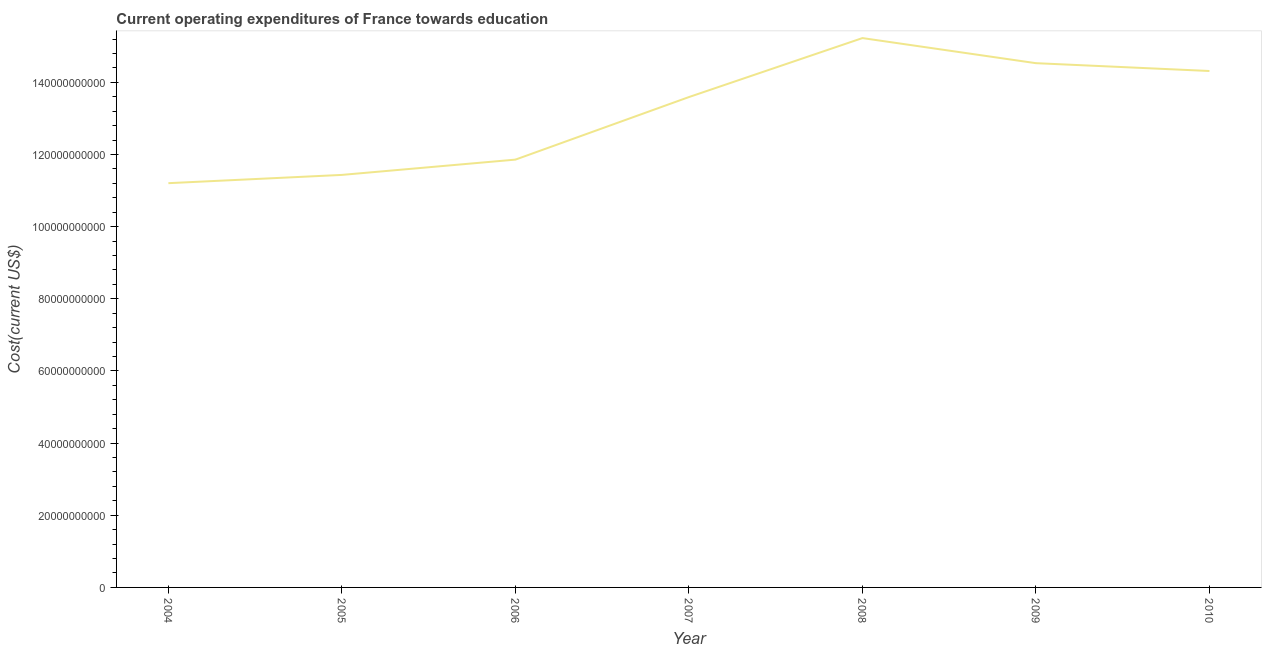What is the education expenditure in 2004?
Offer a very short reply. 1.12e+11. Across all years, what is the maximum education expenditure?
Your answer should be very brief. 1.52e+11. Across all years, what is the minimum education expenditure?
Keep it short and to the point. 1.12e+11. In which year was the education expenditure maximum?
Provide a short and direct response. 2008. In which year was the education expenditure minimum?
Offer a very short reply. 2004. What is the sum of the education expenditure?
Provide a succinct answer. 9.22e+11. What is the difference between the education expenditure in 2005 and 2008?
Your answer should be compact. -3.79e+1. What is the average education expenditure per year?
Provide a succinct answer. 1.32e+11. What is the median education expenditure?
Keep it short and to the point. 1.36e+11. Do a majority of the years between 2004 and 2005 (inclusive) have education expenditure greater than 88000000000 US$?
Offer a very short reply. Yes. What is the ratio of the education expenditure in 2004 to that in 2010?
Offer a terse response. 0.78. Is the education expenditure in 2005 less than that in 2007?
Your answer should be very brief. Yes. Is the difference between the education expenditure in 2006 and 2009 greater than the difference between any two years?
Keep it short and to the point. No. What is the difference between the highest and the second highest education expenditure?
Provide a short and direct response. 6.96e+09. Is the sum of the education expenditure in 2004 and 2005 greater than the maximum education expenditure across all years?
Offer a terse response. Yes. What is the difference between the highest and the lowest education expenditure?
Provide a short and direct response. 4.02e+1. In how many years, is the education expenditure greater than the average education expenditure taken over all years?
Your answer should be very brief. 4. Does the education expenditure monotonically increase over the years?
Give a very brief answer. No. Are the values on the major ticks of Y-axis written in scientific E-notation?
Provide a succinct answer. No. Does the graph contain grids?
Provide a short and direct response. No. What is the title of the graph?
Your response must be concise. Current operating expenditures of France towards education. What is the label or title of the X-axis?
Ensure brevity in your answer.  Year. What is the label or title of the Y-axis?
Ensure brevity in your answer.  Cost(current US$). What is the Cost(current US$) in 2004?
Your answer should be compact. 1.12e+11. What is the Cost(current US$) in 2005?
Your response must be concise. 1.14e+11. What is the Cost(current US$) in 2006?
Keep it short and to the point. 1.19e+11. What is the Cost(current US$) of 2007?
Keep it short and to the point. 1.36e+11. What is the Cost(current US$) of 2008?
Your response must be concise. 1.52e+11. What is the Cost(current US$) in 2009?
Your response must be concise. 1.45e+11. What is the Cost(current US$) of 2010?
Provide a succinct answer. 1.43e+11. What is the difference between the Cost(current US$) in 2004 and 2005?
Keep it short and to the point. -2.29e+09. What is the difference between the Cost(current US$) in 2004 and 2006?
Make the answer very short. -6.53e+09. What is the difference between the Cost(current US$) in 2004 and 2007?
Keep it short and to the point. -2.39e+1. What is the difference between the Cost(current US$) in 2004 and 2008?
Your answer should be compact. -4.02e+1. What is the difference between the Cost(current US$) in 2004 and 2009?
Your answer should be compact. -3.33e+1. What is the difference between the Cost(current US$) in 2004 and 2010?
Provide a succinct answer. -3.11e+1. What is the difference between the Cost(current US$) in 2005 and 2006?
Your answer should be compact. -4.24e+09. What is the difference between the Cost(current US$) in 2005 and 2007?
Offer a terse response. -2.16e+1. What is the difference between the Cost(current US$) in 2005 and 2008?
Provide a short and direct response. -3.79e+1. What is the difference between the Cost(current US$) in 2005 and 2009?
Make the answer very short. -3.10e+1. What is the difference between the Cost(current US$) in 2005 and 2010?
Ensure brevity in your answer.  -2.88e+1. What is the difference between the Cost(current US$) in 2006 and 2007?
Ensure brevity in your answer.  -1.73e+1. What is the difference between the Cost(current US$) in 2006 and 2008?
Your answer should be compact. -3.37e+1. What is the difference between the Cost(current US$) in 2006 and 2009?
Make the answer very short. -2.67e+1. What is the difference between the Cost(current US$) in 2006 and 2010?
Give a very brief answer. -2.46e+1. What is the difference between the Cost(current US$) in 2007 and 2008?
Ensure brevity in your answer.  -1.64e+1. What is the difference between the Cost(current US$) in 2007 and 2009?
Offer a terse response. -9.40e+09. What is the difference between the Cost(current US$) in 2007 and 2010?
Offer a terse response. -7.23e+09. What is the difference between the Cost(current US$) in 2008 and 2009?
Your answer should be compact. 6.96e+09. What is the difference between the Cost(current US$) in 2008 and 2010?
Your answer should be compact. 9.13e+09. What is the difference between the Cost(current US$) in 2009 and 2010?
Provide a short and direct response. 2.17e+09. What is the ratio of the Cost(current US$) in 2004 to that in 2006?
Give a very brief answer. 0.94. What is the ratio of the Cost(current US$) in 2004 to that in 2007?
Keep it short and to the point. 0.82. What is the ratio of the Cost(current US$) in 2004 to that in 2008?
Make the answer very short. 0.74. What is the ratio of the Cost(current US$) in 2004 to that in 2009?
Your response must be concise. 0.77. What is the ratio of the Cost(current US$) in 2004 to that in 2010?
Your answer should be very brief. 0.78. What is the ratio of the Cost(current US$) in 2005 to that in 2007?
Provide a short and direct response. 0.84. What is the ratio of the Cost(current US$) in 2005 to that in 2008?
Make the answer very short. 0.75. What is the ratio of the Cost(current US$) in 2005 to that in 2009?
Give a very brief answer. 0.79. What is the ratio of the Cost(current US$) in 2005 to that in 2010?
Provide a succinct answer. 0.8. What is the ratio of the Cost(current US$) in 2006 to that in 2007?
Make the answer very short. 0.87. What is the ratio of the Cost(current US$) in 2006 to that in 2008?
Your response must be concise. 0.78. What is the ratio of the Cost(current US$) in 2006 to that in 2009?
Your response must be concise. 0.82. What is the ratio of the Cost(current US$) in 2006 to that in 2010?
Make the answer very short. 0.83. What is the ratio of the Cost(current US$) in 2007 to that in 2008?
Ensure brevity in your answer.  0.89. What is the ratio of the Cost(current US$) in 2007 to that in 2009?
Offer a terse response. 0.94. What is the ratio of the Cost(current US$) in 2008 to that in 2009?
Make the answer very short. 1.05. What is the ratio of the Cost(current US$) in 2008 to that in 2010?
Your response must be concise. 1.06. 